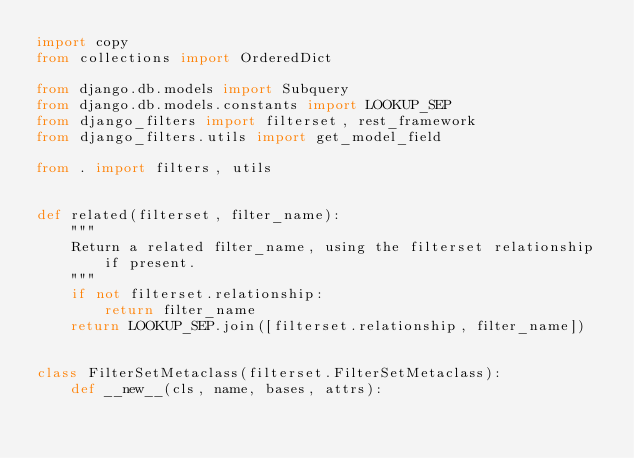<code> <loc_0><loc_0><loc_500><loc_500><_Python_>import copy
from collections import OrderedDict

from django.db.models import Subquery
from django.db.models.constants import LOOKUP_SEP
from django_filters import filterset, rest_framework
from django_filters.utils import get_model_field

from . import filters, utils


def related(filterset, filter_name):
    """
    Return a related filter_name, using the filterset relationship if present.
    """
    if not filterset.relationship:
        return filter_name
    return LOOKUP_SEP.join([filterset.relationship, filter_name])


class FilterSetMetaclass(filterset.FilterSetMetaclass):
    def __new__(cls, name, bases, attrs):</code> 